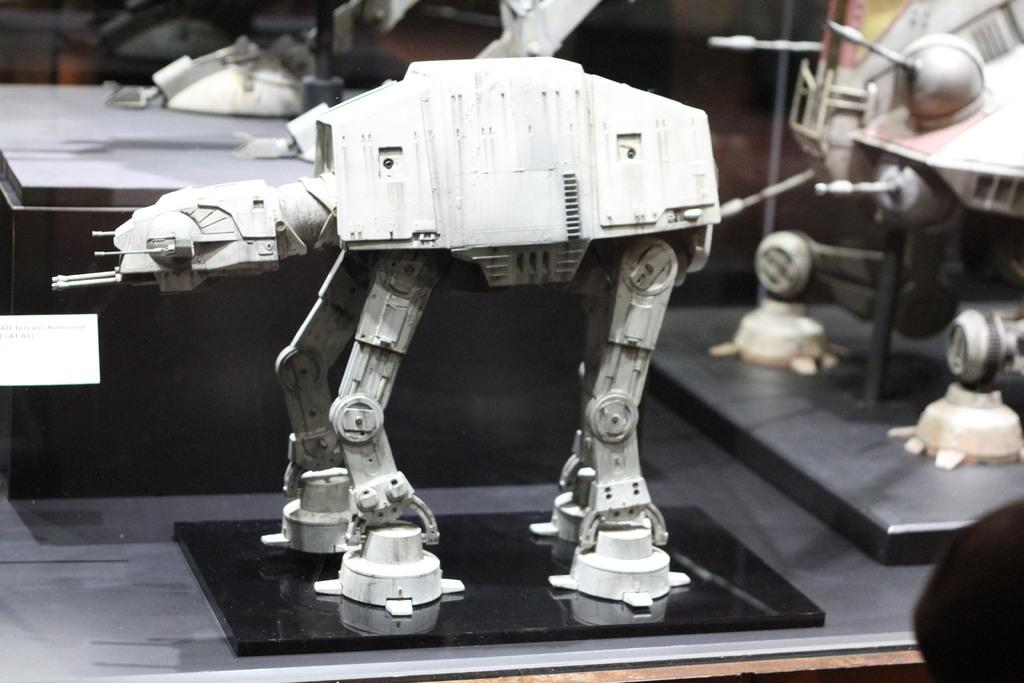What is the main subject of the image? There is a robot in the image. What is the robot placed on? The robot is placed on an object. Are there any other robots visible in the image? Yes, there are other robots behind the first robot. Is there a basin visible in the image? There is no basin present in the image. Are there any cobwebs visible in the image? There is no mention of cobwebs in the provided facts, and therefore we cannot determine if they are present in the image. 